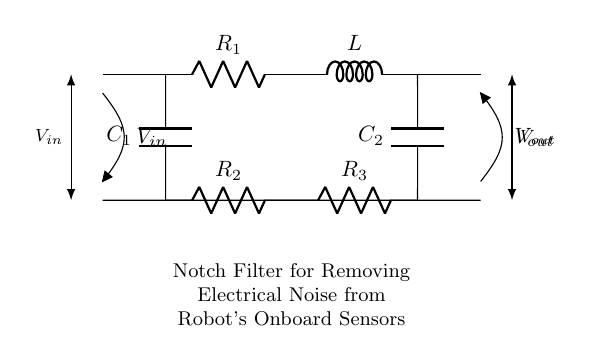What is the input voltage label in this circuit? The input voltage is labeled as V in, which represents the voltage supplied to the circuit from the source.
Answer: V in How many resistors are in the circuit? The circuit contains three resistors labeled R1, R2, and R3, which can be counted from the diagram.
Answer: 3 What type of filter is represented in this circuit? The circuit is identified as a notch filter, which is indicated in the description below the circuit diagram.
Answer: Notch filter Which component is connected in parallel with R1? The capacitor C1 is connected in parallel with resistor R1, as evidenced by its connection at the same nodes.
Answer: C1 What is the purpose of the notch filter in this context? The purpose of this notch filter is to remove electrical noise from the onboard sensors of the robot, as described in the text below the circuit diagram.
Answer: To remove electrical noise What are the labels for the output voltage? The output voltage is labeled as V out, which indicates the voltage across the output of the circuit after filtering.
Answer: V out How are the capacitors arranged in the circuit? The circuit shows that capacitor C1 is in parallel with resistor R2, while capacitor C2 is in parallel with resistor R3, forming a critical part of the notch filter configuration.
Answer: In parallel 